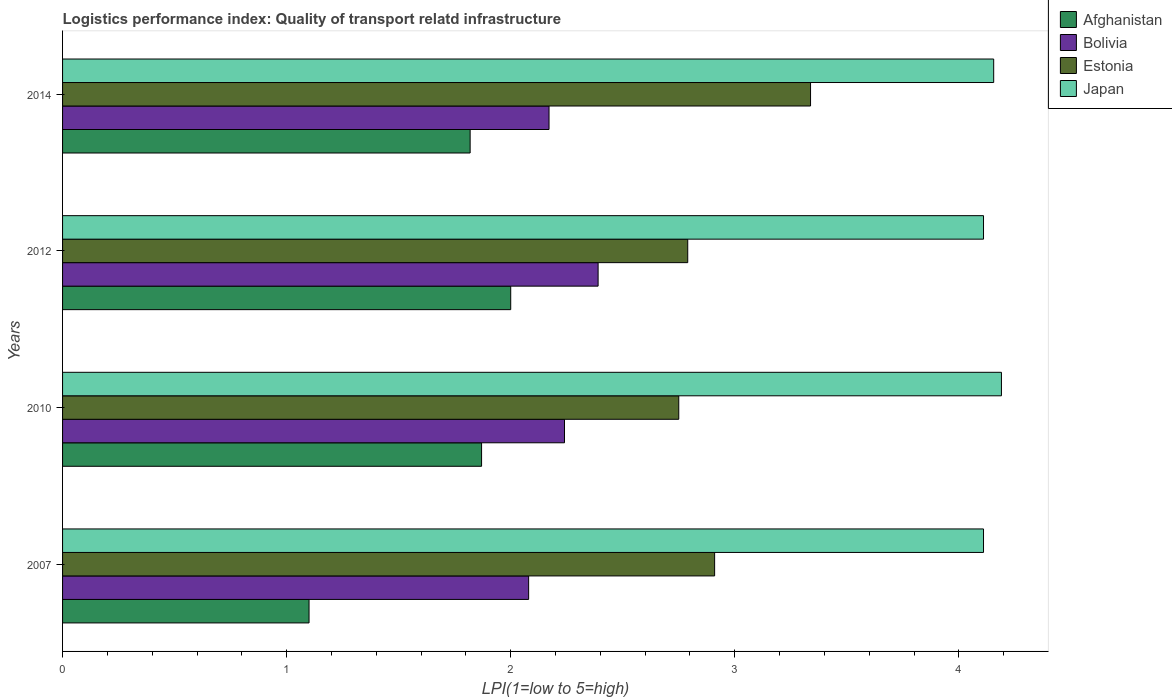How many groups of bars are there?
Your answer should be very brief. 4. Are the number of bars per tick equal to the number of legend labels?
Give a very brief answer. Yes. What is the label of the 1st group of bars from the top?
Provide a succinct answer. 2014. What is the logistics performance index in Japan in 2012?
Your answer should be very brief. 4.11. Across all years, what is the maximum logistics performance index in Estonia?
Offer a very short reply. 3.34. Across all years, what is the minimum logistics performance index in Afghanistan?
Offer a very short reply. 1.1. What is the total logistics performance index in Japan in the graph?
Make the answer very short. 16.57. What is the difference between the logistics performance index in Estonia in 2010 and that in 2014?
Your response must be concise. -0.59. What is the difference between the logistics performance index in Bolivia in 2010 and the logistics performance index in Estonia in 2012?
Provide a succinct answer. -0.55. What is the average logistics performance index in Estonia per year?
Your answer should be very brief. 2.95. In the year 2010, what is the difference between the logistics performance index in Japan and logistics performance index in Estonia?
Your answer should be very brief. 1.44. What is the ratio of the logistics performance index in Estonia in 2007 to that in 2010?
Keep it short and to the point. 1.06. Is the logistics performance index in Bolivia in 2010 less than that in 2012?
Your response must be concise. Yes. What is the difference between the highest and the second highest logistics performance index in Estonia?
Make the answer very short. 0.43. What is the difference between the highest and the lowest logistics performance index in Afghanistan?
Your answer should be compact. 0.9. In how many years, is the logistics performance index in Japan greater than the average logistics performance index in Japan taken over all years?
Ensure brevity in your answer.  2. Is the sum of the logistics performance index in Estonia in 2007 and 2014 greater than the maximum logistics performance index in Japan across all years?
Your answer should be compact. Yes. Is it the case that in every year, the sum of the logistics performance index in Estonia and logistics performance index in Afghanistan is greater than the sum of logistics performance index in Japan and logistics performance index in Bolivia?
Ensure brevity in your answer.  No. What does the 1st bar from the top in 2007 represents?
Your answer should be very brief. Japan. What does the 2nd bar from the bottom in 2007 represents?
Give a very brief answer. Bolivia. Are the values on the major ticks of X-axis written in scientific E-notation?
Offer a terse response. No. What is the title of the graph?
Your answer should be compact. Logistics performance index: Quality of transport relatd infrastructure. Does "Italy" appear as one of the legend labels in the graph?
Provide a short and direct response. No. What is the label or title of the X-axis?
Keep it short and to the point. LPI(1=low to 5=high). What is the label or title of the Y-axis?
Give a very brief answer. Years. What is the LPI(1=low to 5=high) in Bolivia in 2007?
Ensure brevity in your answer.  2.08. What is the LPI(1=low to 5=high) in Estonia in 2007?
Make the answer very short. 2.91. What is the LPI(1=low to 5=high) in Japan in 2007?
Offer a terse response. 4.11. What is the LPI(1=low to 5=high) in Afghanistan in 2010?
Offer a very short reply. 1.87. What is the LPI(1=low to 5=high) of Bolivia in 2010?
Give a very brief answer. 2.24. What is the LPI(1=low to 5=high) of Estonia in 2010?
Make the answer very short. 2.75. What is the LPI(1=low to 5=high) in Japan in 2010?
Offer a very short reply. 4.19. What is the LPI(1=low to 5=high) in Bolivia in 2012?
Offer a terse response. 2.39. What is the LPI(1=low to 5=high) in Estonia in 2012?
Your answer should be compact. 2.79. What is the LPI(1=low to 5=high) of Japan in 2012?
Provide a short and direct response. 4.11. What is the LPI(1=low to 5=high) of Afghanistan in 2014?
Give a very brief answer. 1.82. What is the LPI(1=low to 5=high) of Bolivia in 2014?
Offer a very short reply. 2.17. What is the LPI(1=low to 5=high) of Estonia in 2014?
Provide a short and direct response. 3.34. What is the LPI(1=low to 5=high) of Japan in 2014?
Give a very brief answer. 4.16. Across all years, what is the maximum LPI(1=low to 5=high) in Bolivia?
Ensure brevity in your answer.  2.39. Across all years, what is the maximum LPI(1=low to 5=high) of Estonia?
Provide a short and direct response. 3.34. Across all years, what is the maximum LPI(1=low to 5=high) of Japan?
Offer a terse response. 4.19. Across all years, what is the minimum LPI(1=low to 5=high) of Bolivia?
Provide a short and direct response. 2.08. Across all years, what is the minimum LPI(1=low to 5=high) of Estonia?
Offer a terse response. 2.75. Across all years, what is the minimum LPI(1=low to 5=high) of Japan?
Offer a very short reply. 4.11. What is the total LPI(1=low to 5=high) in Afghanistan in the graph?
Your response must be concise. 6.79. What is the total LPI(1=low to 5=high) in Bolivia in the graph?
Keep it short and to the point. 8.88. What is the total LPI(1=low to 5=high) of Estonia in the graph?
Your answer should be very brief. 11.79. What is the total LPI(1=low to 5=high) of Japan in the graph?
Ensure brevity in your answer.  16.57. What is the difference between the LPI(1=low to 5=high) in Afghanistan in 2007 and that in 2010?
Offer a terse response. -0.77. What is the difference between the LPI(1=low to 5=high) of Bolivia in 2007 and that in 2010?
Keep it short and to the point. -0.16. What is the difference between the LPI(1=low to 5=high) of Estonia in 2007 and that in 2010?
Your answer should be compact. 0.16. What is the difference between the LPI(1=low to 5=high) in Japan in 2007 and that in 2010?
Your response must be concise. -0.08. What is the difference between the LPI(1=low to 5=high) in Afghanistan in 2007 and that in 2012?
Provide a succinct answer. -0.9. What is the difference between the LPI(1=low to 5=high) in Bolivia in 2007 and that in 2012?
Your response must be concise. -0.31. What is the difference between the LPI(1=low to 5=high) of Estonia in 2007 and that in 2012?
Give a very brief answer. 0.12. What is the difference between the LPI(1=low to 5=high) in Afghanistan in 2007 and that in 2014?
Your response must be concise. -0.72. What is the difference between the LPI(1=low to 5=high) in Bolivia in 2007 and that in 2014?
Your response must be concise. -0.09. What is the difference between the LPI(1=low to 5=high) of Estonia in 2007 and that in 2014?
Your response must be concise. -0.43. What is the difference between the LPI(1=low to 5=high) in Japan in 2007 and that in 2014?
Give a very brief answer. -0.05. What is the difference between the LPI(1=low to 5=high) in Afghanistan in 2010 and that in 2012?
Provide a succinct answer. -0.13. What is the difference between the LPI(1=low to 5=high) in Estonia in 2010 and that in 2012?
Keep it short and to the point. -0.04. What is the difference between the LPI(1=low to 5=high) of Japan in 2010 and that in 2012?
Your response must be concise. 0.08. What is the difference between the LPI(1=low to 5=high) in Afghanistan in 2010 and that in 2014?
Your answer should be compact. 0.05. What is the difference between the LPI(1=low to 5=high) of Bolivia in 2010 and that in 2014?
Provide a succinct answer. 0.07. What is the difference between the LPI(1=low to 5=high) of Estonia in 2010 and that in 2014?
Make the answer very short. -0.59. What is the difference between the LPI(1=low to 5=high) in Japan in 2010 and that in 2014?
Offer a terse response. 0.03. What is the difference between the LPI(1=low to 5=high) of Afghanistan in 2012 and that in 2014?
Provide a succinct answer. 0.18. What is the difference between the LPI(1=low to 5=high) of Bolivia in 2012 and that in 2014?
Give a very brief answer. 0.22. What is the difference between the LPI(1=low to 5=high) of Estonia in 2012 and that in 2014?
Ensure brevity in your answer.  -0.55. What is the difference between the LPI(1=low to 5=high) of Japan in 2012 and that in 2014?
Ensure brevity in your answer.  -0.05. What is the difference between the LPI(1=low to 5=high) in Afghanistan in 2007 and the LPI(1=low to 5=high) in Bolivia in 2010?
Provide a succinct answer. -1.14. What is the difference between the LPI(1=low to 5=high) of Afghanistan in 2007 and the LPI(1=low to 5=high) of Estonia in 2010?
Your response must be concise. -1.65. What is the difference between the LPI(1=low to 5=high) of Afghanistan in 2007 and the LPI(1=low to 5=high) of Japan in 2010?
Make the answer very short. -3.09. What is the difference between the LPI(1=low to 5=high) of Bolivia in 2007 and the LPI(1=low to 5=high) of Estonia in 2010?
Give a very brief answer. -0.67. What is the difference between the LPI(1=low to 5=high) in Bolivia in 2007 and the LPI(1=low to 5=high) in Japan in 2010?
Offer a very short reply. -2.11. What is the difference between the LPI(1=low to 5=high) in Estonia in 2007 and the LPI(1=low to 5=high) in Japan in 2010?
Keep it short and to the point. -1.28. What is the difference between the LPI(1=low to 5=high) of Afghanistan in 2007 and the LPI(1=low to 5=high) of Bolivia in 2012?
Provide a succinct answer. -1.29. What is the difference between the LPI(1=low to 5=high) in Afghanistan in 2007 and the LPI(1=low to 5=high) in Estonia in 2012?
Your answer should be compact. -1.69. What is the difference between the LPI(1=low to 5=high) in Afghanistan in 2007 and the LPI(1=low to 5=high) in Japan in 2012?
Provide a short and direct response. -3.01. What is the difference between the LPI(1=low to 5=high) of Bolivia in 2007 and the LPI(1=low to 5=high) of Estonia in 2012?
Offer a terse response. -0.71. What is the difference between the LPI(1=low to 5=high) of Bolivia in 2007 and the LPI(1=low to 5=high) of Japan in 2012?
Your answer should be very brief. -2.03. What is the difference between the LPI(1=low to 5=high) of Estonia in 2007 and the LPI(1=low to 5=high) of Japan in 2012?
Provide a short and direct response. -1.2. What is the difference between the LPI(1=low to 5=high) in Afghanistan in 2007 and the LPI(1=low to 5=high) in Bolivia in 2014?
Give a very brief answer. -1.07. What is the difference between the LPI(1=low to 5=high) of Afghanistan in 2007 and the LPI(1=low to 5=high) of Estonia in 2014?
Keep it short and to the point. -2.24. What is the difference between the LPI(1=low to 5=high) in Afghanistan in 2007 and the LPI(1=low to 5=high) in Japan in 2014?
Offer a terse response. -3.06. What is the difference between the LPI(1=low to 5=high) in Bolivia in 2007 and the LPI(1=low to 5=high) in Estonia in 2014?
Your answer should be very brief. -1.26. What is the difference between the LPI(1=low to 5=high) in Bolivia in 2007 and the LPI(1=low to 5=high) in Japan in 2014?
Give a very brief answer. -2.08. What is the difference between the LPI(1=low to 5=high) of Estonia in 2007 and the LPI(1=low to 5=high) of Japan in 2014?
Ensure brevity in your answer.  -1.25. What is the difference between the LPI(1=low to 5=high) in Afghanistan in 2010 and the LPI(1=low to 5=high) in Bolivia in 2012?
Make the answer very short. -0.52. What is the difference between the LPI(1=low to 5=high) of Afghanistan in 2010 and the LPI(1=low to 5=high) of Estonia in 2012?
Keep it short and to the point. -0.92. What is the difference between the LPI(1=low to 5=high) of Afghanistan in 2010 and the LPI(1=low to 5=high) of Japan in 2012?
Offer a very short reply. -2.24. What is the difference between the LPI(1=low to 5=high) in Bolivia in 2010 and the LPI(1=low to 5=high) in Estonia in 2012?
Your answer should be compact. -0.55. What is the difference between the LPI(1=low to 5=high) in Bolivia in 2010 and the LPI(1=low to 5=high) in Japan in 2012?
Your answer should be compact. -1.87. What is the difference between the LPI(1=low to 5=high) in Estonia in 2010 and the LPI(1=low to 5=high) in Japan in 2012?
Your answer should be compact. -1.36. What is the difference between the LPI(1=low to 5=high) in Afghanistan in 2010 and the LPI(1=low to 5=high) in Bolivia in 2014?
Make the answer very short. -0.3. What is the difference between the LPI(1=low to 5=high) of Afghanistan in 2010 and the LPI(1=low to 5=high) of Estonia in 2014?
Make the answer very short. -1.47. What is the difference between the LPI(1=low to 5=high) of Afghanistan in 2010 and the LPI(1=low to 5=high) of Japan in 2014?
Your response must be concise. -2.29. What is the difference between the LPI(1=low to 5=high) in Bolivia in 2010 and the LPI(1=low to 5=high) in Estonia in 2014?
Keep it short and to the point. -1.1. What is the difference between the LPI(1=low to 5=high) of Bolivia in 2010 and the LPI(1=low to 5=high) of Japan in 2014?
Your answer should be compact. -1.92. What is the difference between the LPI(1=low to 5=high) in Estonia in 2010 and the LPI(1=low to 5=high) in Japan in 2014?
Offer a very short reply. -1.41. What is the difference between the LPI(1=low to 5=high) in Afghanistan in 2012 and the LPI(1=low to 5=high) in Bolivia in 2014?
Ensure brevity in your answer.  -0.17. What is the difference between the LPI(1=low to 5=high) in Afghanistan in 2012 and the LPI(1=low to 5=high) in Estonia in 2014?
Your answer should be very brief. -1.34. What is the difference between the LPI(1=low to 5=high) in Afghanistan in 2012 and the LPI(1=low to 5=high) in Japan in 2014?
Your answer should be compact. -2.16. What is the difference between the LPI(1=low to 5=high) in Bolivia in 2012 and the LPI(1=low to 5=high) in Estonia in 2014?
Provide a short and direct response. -0.95. What is the difference between the LPI(1=low to 5=high) of Bolivia in 2012 and the LPI(1=low to 5=high) of Japan in 2014?
Your answer should be very brief. -1.77. What is the difference between the LPI(1=low to 5=high) of Estonia in 2012 and the LPI(1=low to 5=high) of Japan in 2014?
Your response must be concise. -1.37. What is the average LPI(1=low to 5=high) of Afghanistan per year?
Ensure brevity in your answer.  1.7. What is the average LPI(1=low to 5=high) in Bolivia per year?
Provide a short and direct response. 2.22. What is the average LPI(1=low to 5=high) in Estonia per year?
Offer a terse response. 2.95. What is the average LPI(1=low to 5=high) in Japan per year?
Your answer should be compact. 4.14. In the year 2007, what is the difference between the LPI(1=low to 5=high) of Afghanistan and LPI(1=low to 5=high) of Bolivia?
Ensure brevity in your answer.  -0.98. In the year 2007, what is the difference between the LPI(1=low to 5=high) in Afghanistan and LPI(1=low to 5=high) in Estonia?
Give a very brief answer. -1.81. In the year 2007, what is the difference between the LPI(1=low to 5=high) of Afghanistan and LPI(1=low to 5=high) of Japan?
Offer a terse response. -3.01. In the year 2007, what is the difference between the LPI(1=low to 5=high) of Bolivia and LPI(1=low to 5=high) of Estonia?
Your answer should be very brief. -0.83. In the year 2007, what is the difference between the LPI(1=low to 5=high) in Bolivia and LPI(1=low to 5=high) in Japan?
Your answer should be very brief. -2.03. In the year 2010, what is the difference between the LPI(1=low to 5=high) of Afghanistan and LPI(1=low to 5=high) of Bolivia?
Offer a terse response. -0.37. In the year 2010, what is the difference between the LPI(1=low to 5=high) in Afghanistan and LPI(1=low to 5=high) in Estonia?
Ensure brevity in your answer.  -0.88. In the year 2010, what is the difference between the LPI(1=low to 5=high) in Afghanistan and LPI(1=low to 5=high) in Japan?
Offer a terse response. -2.32. In the year 2010, what is the difference between the LPI(1=low to 5=high) in Bolivia and LPI(1=low to 5=high) in Estonia?
Keep it short and to the point. -0.51. In the year 2010, what is the difference between the LPI(1=low to 5=high) of Bolivia and LPI(1=low to 5=high) of Japan?
Offer a very short reply. -1.95. In the year 2010, what is the difference between the LPI(1=low to 5=high) of Estonia and LPI(1=low to 5=high) of Japan?
Your answer should be compact. -1.44. In the year 2012, what is the difference between the LPI(1=low to 5=high) of Afghanistan and LPI(1=low to 5=high) of Bolivia?
Make the answer very short. -0.39. In the year 2012, what is the difference between the LPI(1=low to 5=high) of Afghanistan and LPI(1=low to 5=high) of Estonia?
Keep it short and to the point. -0.79. In the year 2012, what is the difference between the LPI(1=low to 5=high) of Afghanistan and LPI(1=low to 5=high) of Japan?
Offer a very short reply. -2.11. In the year 2012, what is the difference between the LPI(1=low to 5=high) of Bolivia and LPI(1=low to 5=high) of Estonia?
Your answer should be very brief. -0.4. In the year 2012, what is the difference between the LPI(1=low to 5=high) of Bolivia and LPI(1=low to 5=high) of Japan?
Make the answer very short. -1.72. In the year 2012, what is the difference between the LPI(1=low to 5=high) in Estonia and LPI(1=low to 5=high) in Japan?
Provide a short and direct response. -1.32. In the year 2014, what is the difference between the LPI(1=low to 5=high) in Afghanistan and LPI(1=low to 5=high) in Bolivia?
Offer a very short reply. -0.35. In the year 2014, what is the difference between the LPI(1=low to 5=high) of Afghanistan and LPI(1=low to 5=high) of Estonia?
Your answer should be very brief. -1.52. In the year 2014, what is the difference between the LPI(1=low to 5=high) in Afghanistan and LPI(1=low to 5=high) in Japan?
Your answer should be compact. -2.34. In the year 2014, what is the difference between the LPI(1=low to 5=high) in Bolivia and LPI(1=low to 5=high) in Estonia?
Your answer should be compact. -1.17. In the year 2014, what is the difference between the LPI(1=low to 5=high) of Bolivia and LPI(1=low to 5=high) of Japan?
Give a very brief answer. -1.98. In the year 2014, what is the difference between the LPI(1=low to 5=high) of Estonia and LPI(1=low to 5=high) of Japan?
Offer a very short reply. -0.82. What is the ratio of the LPI(1=low to 5=high) in Afghanistan in 2007 to that in 2010?
Offer a very short reply. 0.59. What is the ratio of the LPI(1=low to 5=high) of Estonia in 2007 to that in 2010?
Give a very brief answer. 1.06. What is the ratio of the LPI(1=low to 5=high) in Japan in 2007 to that in 2010?
Give a very brief answer. 0.98. What is the ratio of the LPI(1=low to 5=high) of Afghanistan in 2007 to that in 2012?
Give a very brief answer. 0.55. What is the ratio of the LPI(1=low to 5=high) in Bolivia in 2007 to that in 2012?
Your answer should be compact. 0.87. What is the ratio of the LPI(1=low to 5=high) in Estonia in 2007 to that in 2012?
Offer a terse response. 1.04. What is the ratio of the LPI(1=low to 5=high) in Afghanistan in 2007 to that in 2014?
Provide a short and direct response. 0.6. What is the ratio of the LPI(1=low to 5=high) in Bolivia in 2007 to that in 2014?
Offer a terse response. 0.96. What is the ratio of the LPI(1=low to 5=high) in Estonia in 2007 to that in 2014?
Make the answer very short. 0.87. What is the ratio of the LPI(1=low to 5=high) of Afghanistan in 2010 to that in 2012?
Keep it short and to the point. 0.94. What is the ratio of the LPI(1=low to 5=high) in Bolivia in 2010 to that in 2012?
Offer a terse response. 0.94. What is the ratio of the LPI(1=low to 5=high) of Estonia in 2010 to that in 2012?
Your answer should be very brief. 0.99. What is the ratio of the LPI(1=low to 5=high) of Japan in 2010 to that in 2012?
Provide a short and direct response. 1.02. What is the ratio of the LPI(1=low to 5=high) of Afghanistan in 2010 to that in 2014?
Offer a terse response. 1.03. What is the ratio of the LPI(1=low to 5=high) of Bolivia in 2010 to that in 2014?
Give a very brief answer. 1.03. What is the ratio of the LPI(1=low to 5=high) in Estonia in 2010 to that in 2014?
Make the answer very short. 0.82. What is the ratio of the LPI(1=low to 5=high) in Japan in 2010 to that in 2014?
Offer a terse response. 1.01. What is the ratio of the LPI(1=low to 5=high) of Afghanistan in 2012 to that in 2014?
Your answer should be very brief. 1.1. What is the ratio of the LPI(1=low to 5=high) of Bolivia in 2012 to that in 2014?
Your answer should be compact. 1.1. What is the ratio of the LPI(1=low to 5=high) of Estonia in 2012 to that in 2014?
Offer a very short reply. 0.84. What is the difference between the highest and the second highest LPI(1=low to 5=high) of Afghanistan?
Your response must be concise. 0.13. What is the difference between the highest and the second highest LPI(1=low to 5=high) in Estonia?
Your answer should be very brief. 0.43. What is the difference between the highest and the second highest LPI(1=low to 5=high) of Japan?
Ensure brevity in your answer.  0.03. What is the difference between the highest and the lowest LPI(1=low to 5=high) of Afghanistan?
Provide a succinct answer. 0.9. What is the difference between the highest and the lowest LPI(1=low to 5=high) of Bolivia?
Ensure brevity in your answer.  0.31. What is the difference between the highest and the lowest LPI(1=low to 5=high) of Estonia?
Your response must be concise. 0.59. 